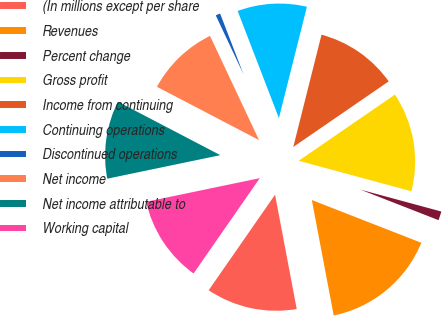Convert chart to OTSL. <chart><loc_0><loc_0><loc_500><loc_500><pie_chart><fcel>(In millions except per share<fcel>Revenues<fcel>Percent change<fcel>Gross profit<fcel>Income from continuing<fcel>Continuing operations<fcel>Discontinued operations<fcel>Net income<fcel>Net income attributable to<fcel>Working capital<nl><fcel>12.64%<fcel>16.09%<fcel>1.72%<fcel>13.79%<fcel>11.49%<fcel>9.77%<fcel>1.15%<fcel>10.34%<fcel>10.92%<fcel>12.07%<nl></chart> 